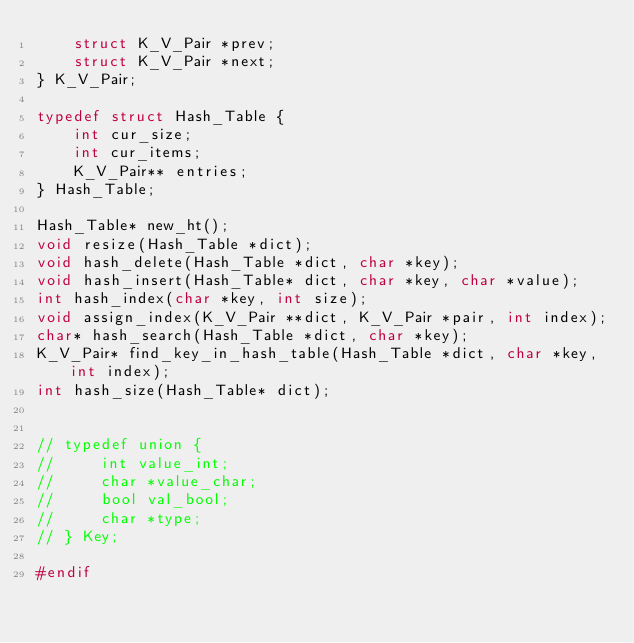<code> <loc_0><loc_0><loc_500><loc_500><_C_>    struct K_V_Pair *prev;
    struct K_V_Pair *next;
} K_V_Pair;

typedef struct Hash_Table {
    int cur_size;
    int cur_items;
    K_V_Pair** entries;
} Hash_Table;

Hash_Table* new_ht();
void resize(Hash_Table *dict);
void hash_delete(Hash_Table *dict, char *key);
void hash_insert(Hash_Table* dict, char *key, char *value);
int hash_index(char *key, int size);
void assign_index(K_V_Pair **dict, K_V_Pair *pair, int index);
char* hash_search(Hash_Table *dict, char *key);
K_V_Pair* find_key_in_hash_table(Hash_Table *dict, char *key, int index);
int hash_size(Hash_Table* dict);


// typedef union {
//     int value_int;
//     char *value_char;
//     bool val_bool;
//     char *type;
// } Key;

#endif
</code> 